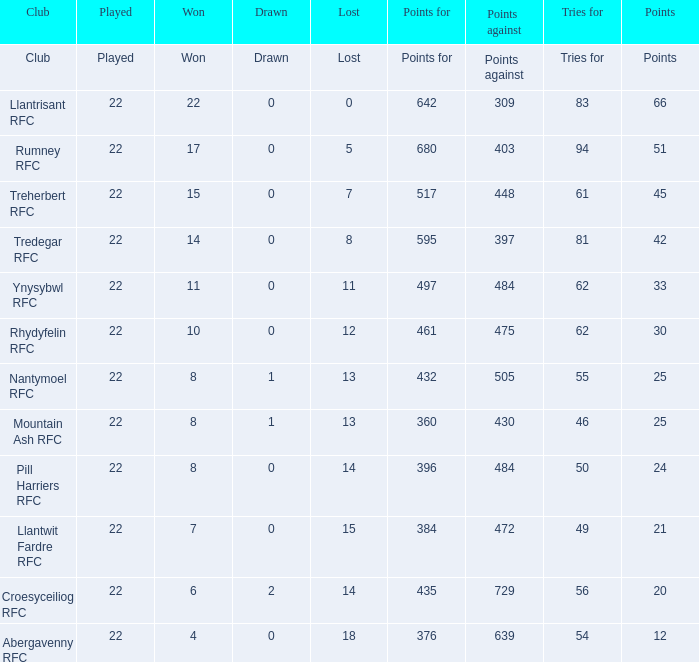How many points for were scored by the team that won exactly 22? 642.0. 